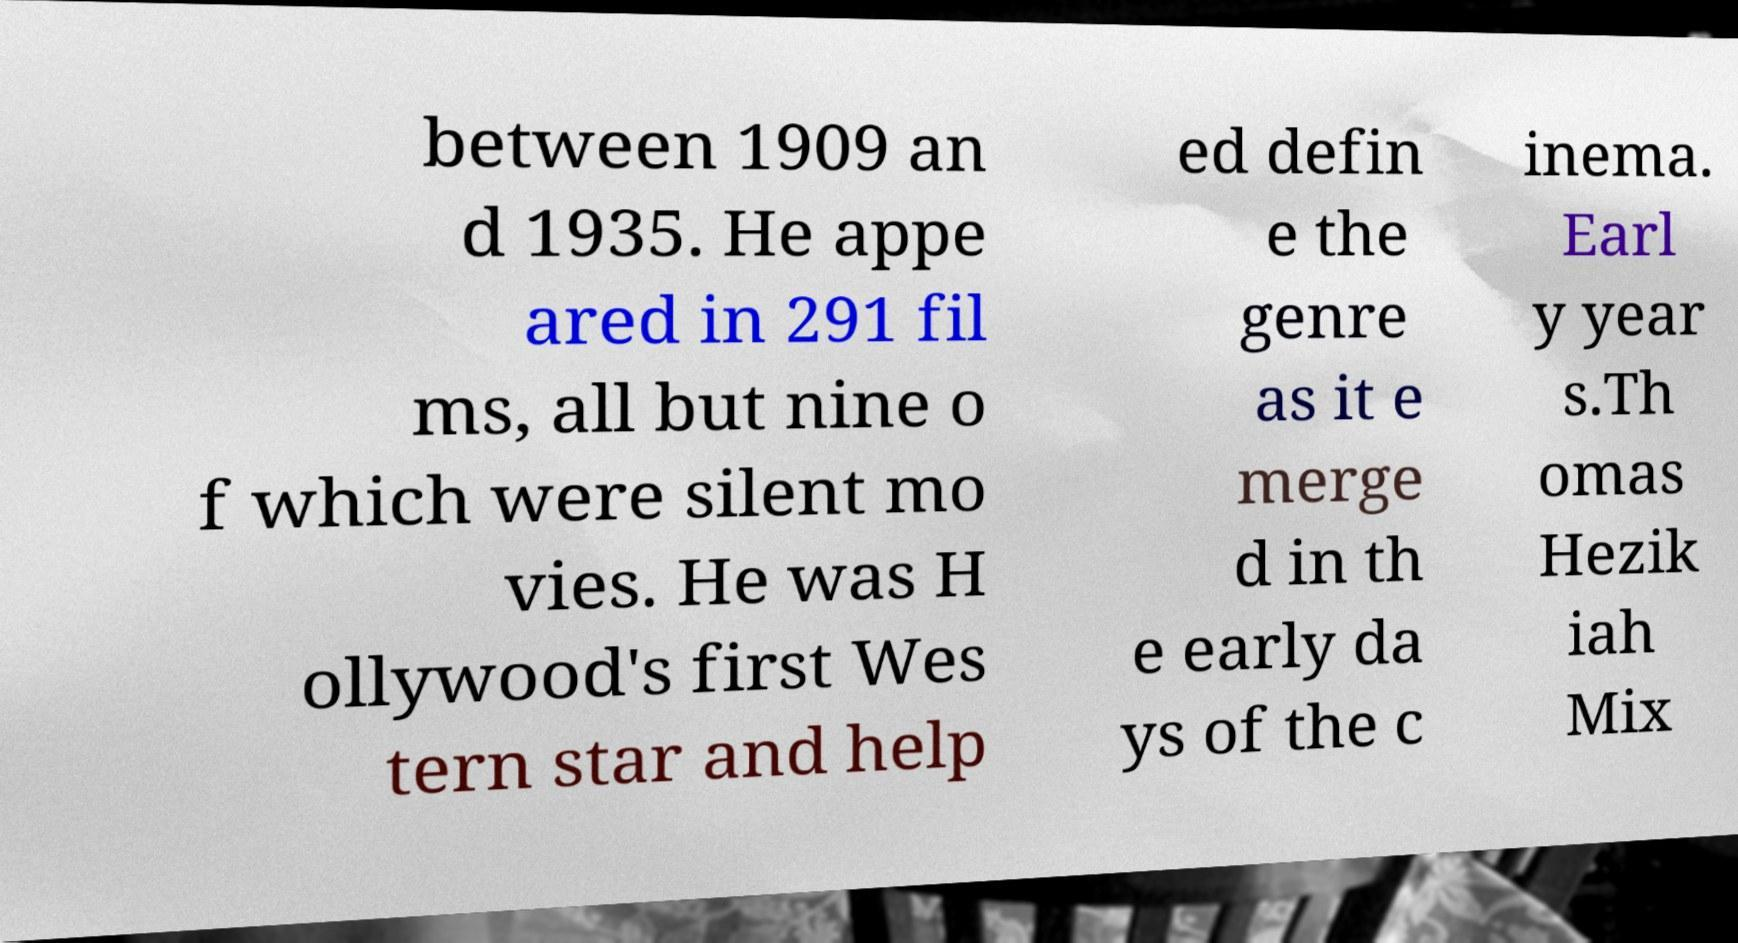There's text embedded in this image that I need extracted. Can you transcribe it verbatim? between 1909 an d 1935. He appe ared in 291 fil ms, all but nine o f which were silent mo vies. He was H ollywood's first Wes tern star and help ed defin e the genre as it e merge d in th e early da ys of the c inema. Earl y year s.Th omas Hezik iah Mix 